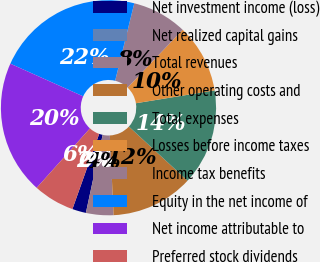<chart> <loc_0><loc_0><loc_500><loc_500><pie_chart><fcel>Net investment income (loss)<fcel>Net realized capital gains<fcel>Total revenues<fcel>Other operating costs and<fcel>Total expenses<fcel>Losses before income taxes<fcel>Income tax benefits<fcel>Equity in the net income of<fcel>Net income attributable to<fcel>Preferred stock dividends<nl><fcel>2.07%<fcel>0.0%<fcel>4.13%<fcel>12.38%<fcel>14.44%<fcel>10.32%<fcel>8.25%<fcel>22.14%<fcel>20.08%<fcel>6.19%<nl></chart> 